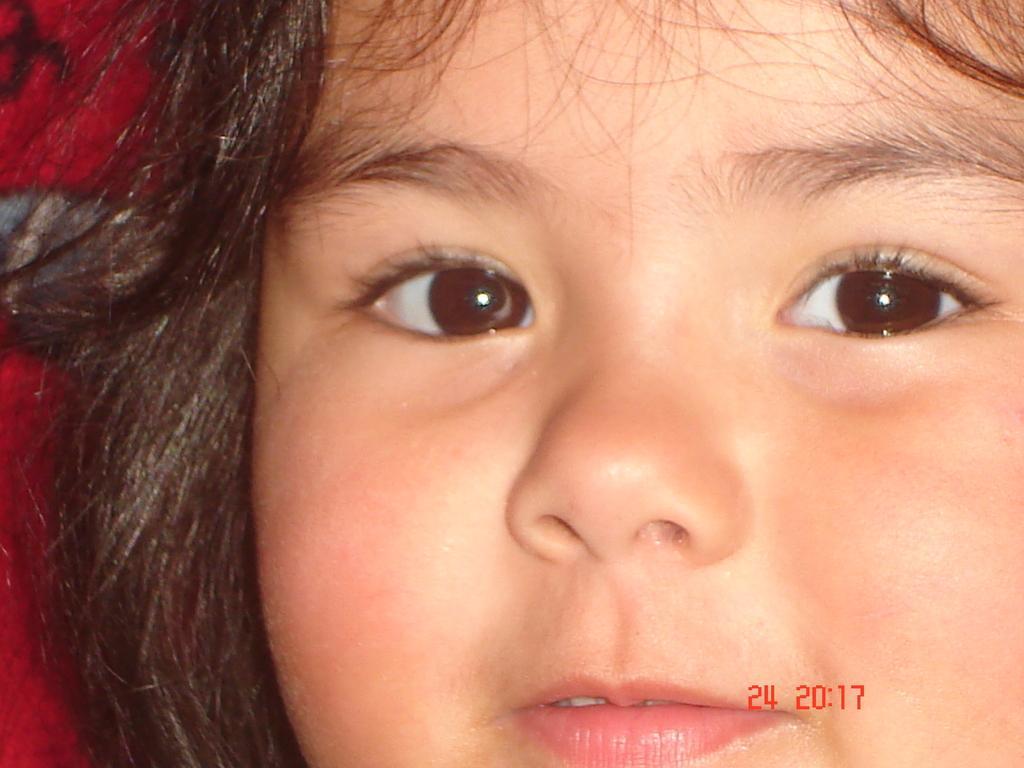How would you summarize this image in a sentence or two? In this image we can see a face of a child and there is some text at the bottom of the image. 